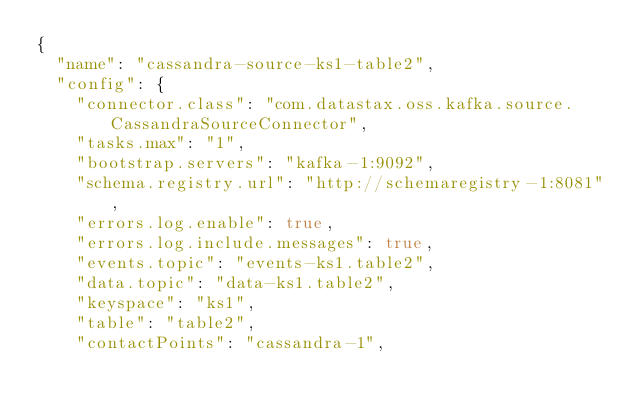Convert code to text. <code><loc_0><loc_0><loc_500><loc_500><_YAML_>{
  "name": "cassandra-source-ks1-table2",
  "config": {
    "connector.class": "com.datastax.oss.kafka.source.CassandraSourceConnector",
    "tasks.max": "1",
    "bootstrap.servers": "kafka-1:9092",
    "schema.registry.url": "http://schemaregistry-1:8081",
    "errors.log.enable": true,
    "errors.log.include.messages": true,
    "events.topic": "events-ks1.table2",
    "data.topic": "data-ks1.table2",
    "keyspace": "ks1",
    "table": "table2",
    "contactPoints": "cassandra-1",</code> 